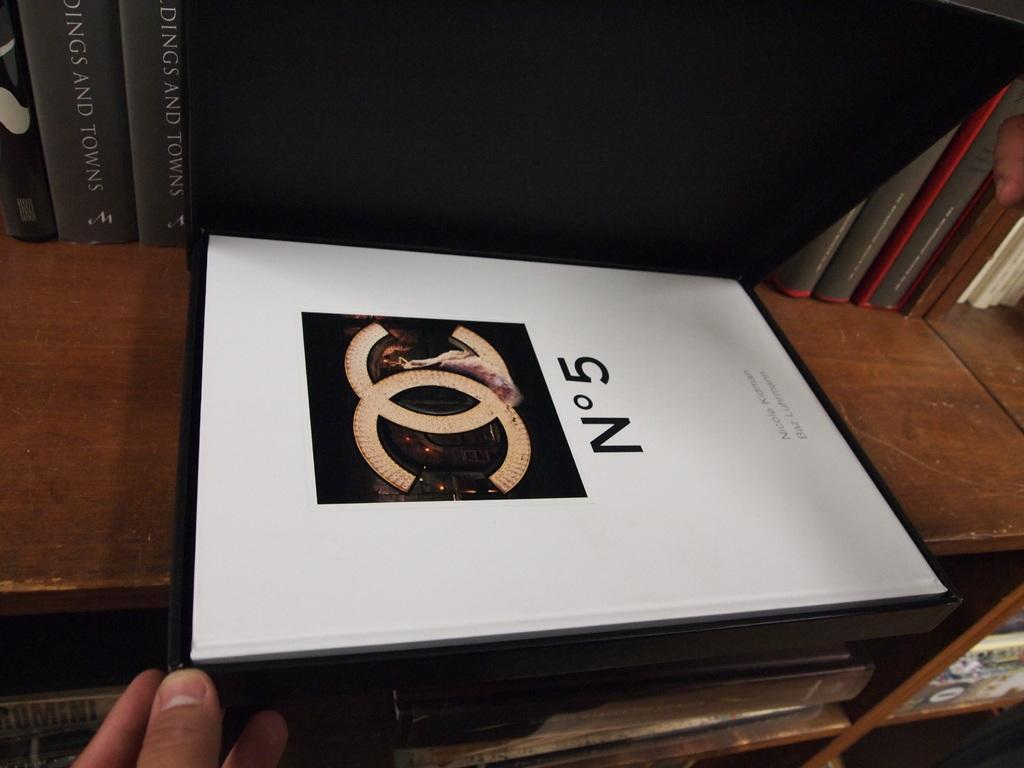<image>
Provide a brief description of the given image. An elegant box of No 5 sits on the shelf. 